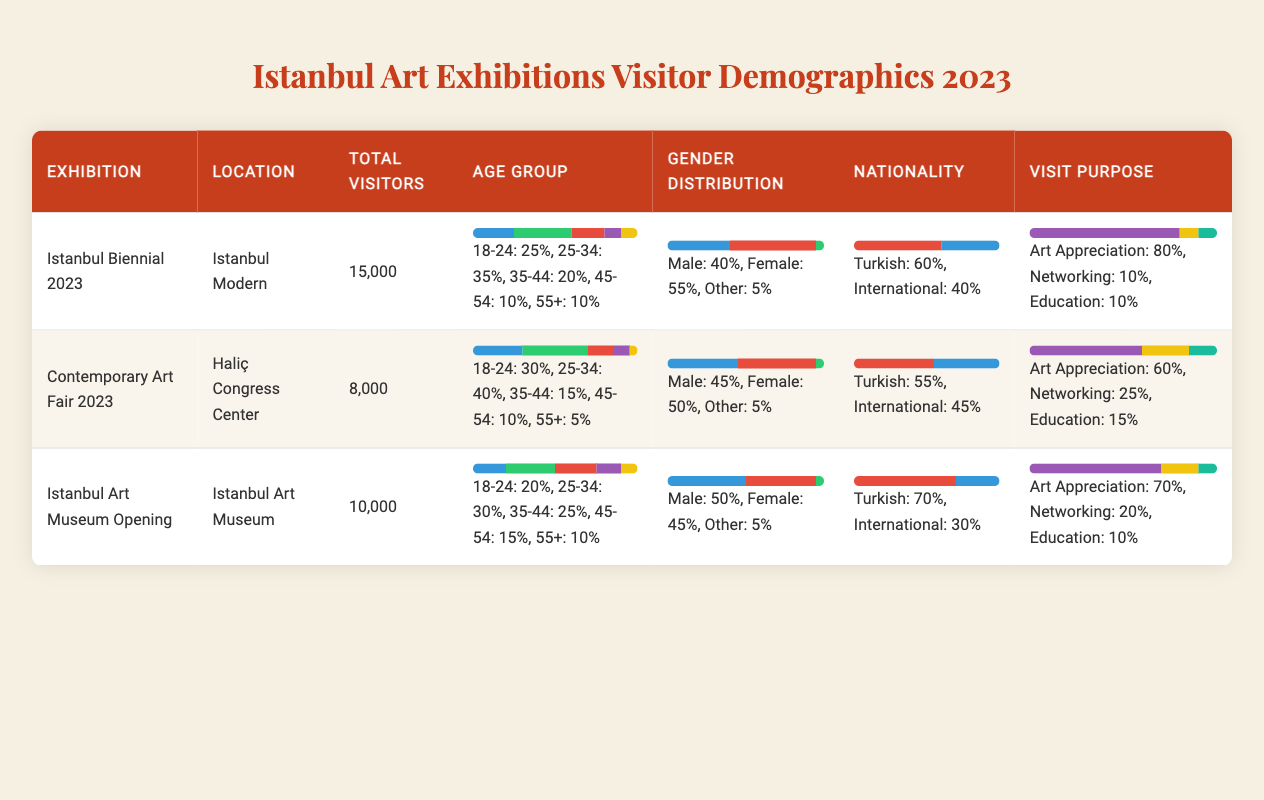What is the total number of visitors for the Istanbul Biennial 2023? The table shows that the total number of visitors for the Istanbul Biennial 2023 is 15,000.
Answer: 15,000 Which exhibition had the highest percentage of international visitors? The Istanbul Biennial 2023 had 40% international visitors, while the Contemporary Art Fair 2023 had 45%. Thus, the Contemporary Art Fair had the highest percentage of international visitors.
Answer: Contemporary Art Fair 2023 What is the average percentage of art appreciation across all exhibitions? The percentages for art appreciation are 80% for the Istanbul Biennial, 60% for the Contemporary Art Fair, and 70% for the Istanbul Art Museum Opening. Adding these gives (80 + 60 + 70) = 210. Dividing by 3 exhibitions gives an average of 210 / 3 = 70%.
Answer: 70% Is the number of visitors for the Contemporary Art Fair greater than the average number of visitors for all three exhibitions? The total visitors for the Contemporary Art Fair is 8,000. The total visitors across all exhibitions is (15,000 + 8,000 + 10,000) = 33,000, and the average is 33,000 / 3 = 11,000. Since 8,000 is less than 11,000, the answer is no.
Answer: No Which age group had the highest percentage of visitors at the Istanbul Art Museum Opening? At the Istanbul Art Museum Opening, the age group percentages are: 18-24 (20%), 25-34 (30%), 35-44 (25%), 45-54 (15%), and 55+ (10%). The highest percentage is from the age group 25-34 at 30%.
Answer: 25-34 What percentage of female visitors attended the Contemporary Art Fair? The Gender Distribution for the Contemporary Art Fair indicates that female visitors made up 50% of the total visitors.
Answer: 50% Did the Istanbul Biennial 2023 have a higher percentage of female visitors than the Istanbul Art Museum Opening? The Istanbul Biennial had 55% female visitors, while the Istanbul Art Museum Opening had 45%. Thus, the Istanbul Biennial had a higher percentage of female visitors.
Answer: Yes What is the total percentage of visitors who came for education purposes across all exhibitions? For the Istanbul Biennial, education purposes accounted for 10%. For the Contemporary Art Fair, it was 15%, and for the Istanbul Art Museum Opening, it was 10%. Adding these gives (10 + 15 + 10) = 35%.
Answer: 35% 